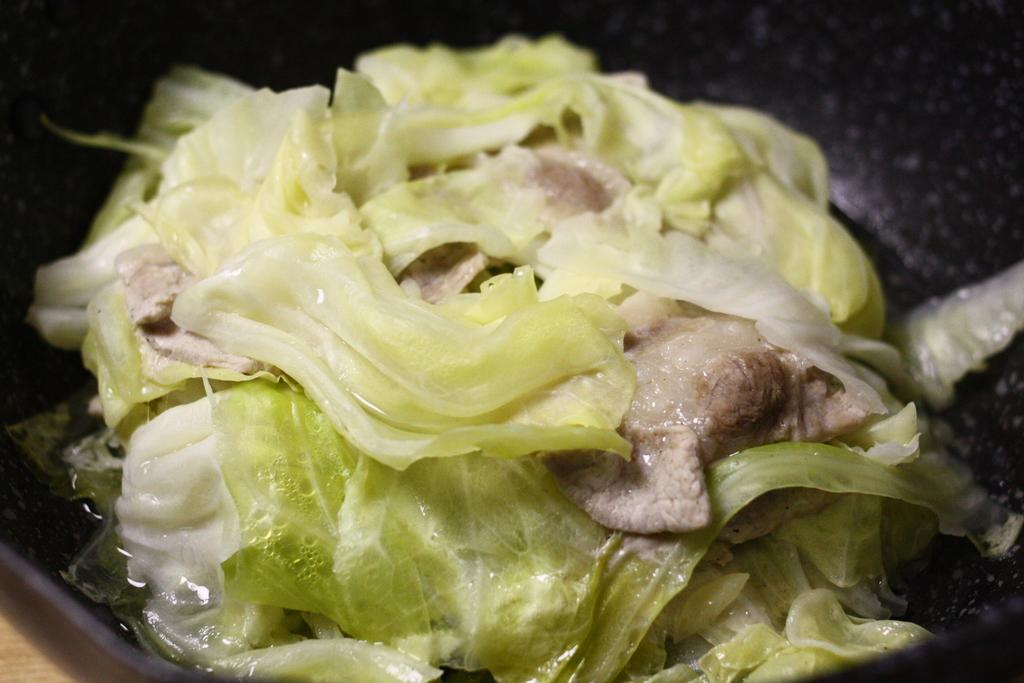What is the main subject of the image? There is a food item in the image. Where is the food item located in the image? The food item is in the center of the image. How many shoes are visible in the image? There are no shoes present in the image. What is the afterthought of the person who created the image? We cannot determine the afterthought of the person who created the image from the information provided. 